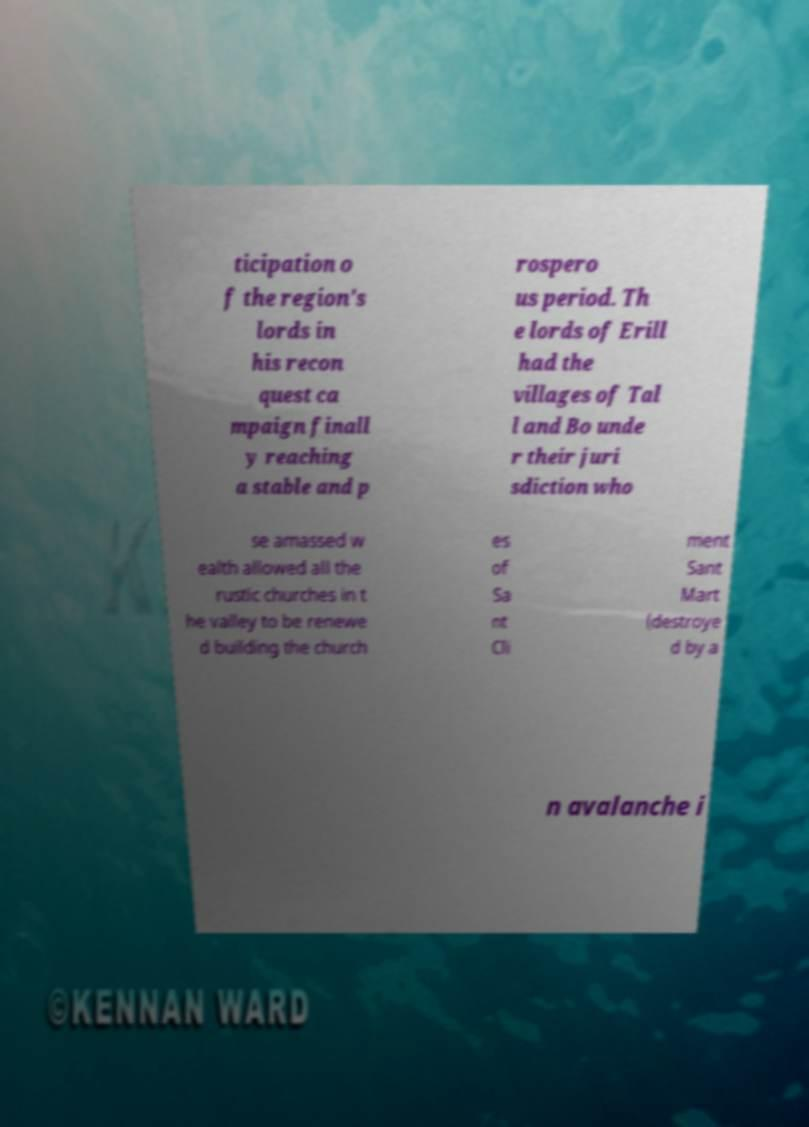Could you assist in decoding the text presented in this image and type it out clearly? ticipation o f the region's lords in his recon quest ca mpaign finall y reaching a stable and p rospero us period. Th e lords of Erill had the villages of Tal l and Bo unde r their juri sdiction who se amassed w ealth allowed all the rustic churches in t he valley to be renewe d building the church es of Sa nt Cli ment Sant Mart (destroye d by a n avalanche i 